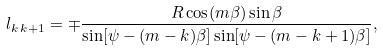<formula> <loc_0><loc_0><loc_500><loc_500>l _ { k \, k + 1 } = \mp \frac { R \cos ( m \beta ) \sin \beta } { \sin [ \psi - ( m - k ) \beta ] \sin [ \psi - ( m - k + 1 ) \beta ] } ,</formula> 